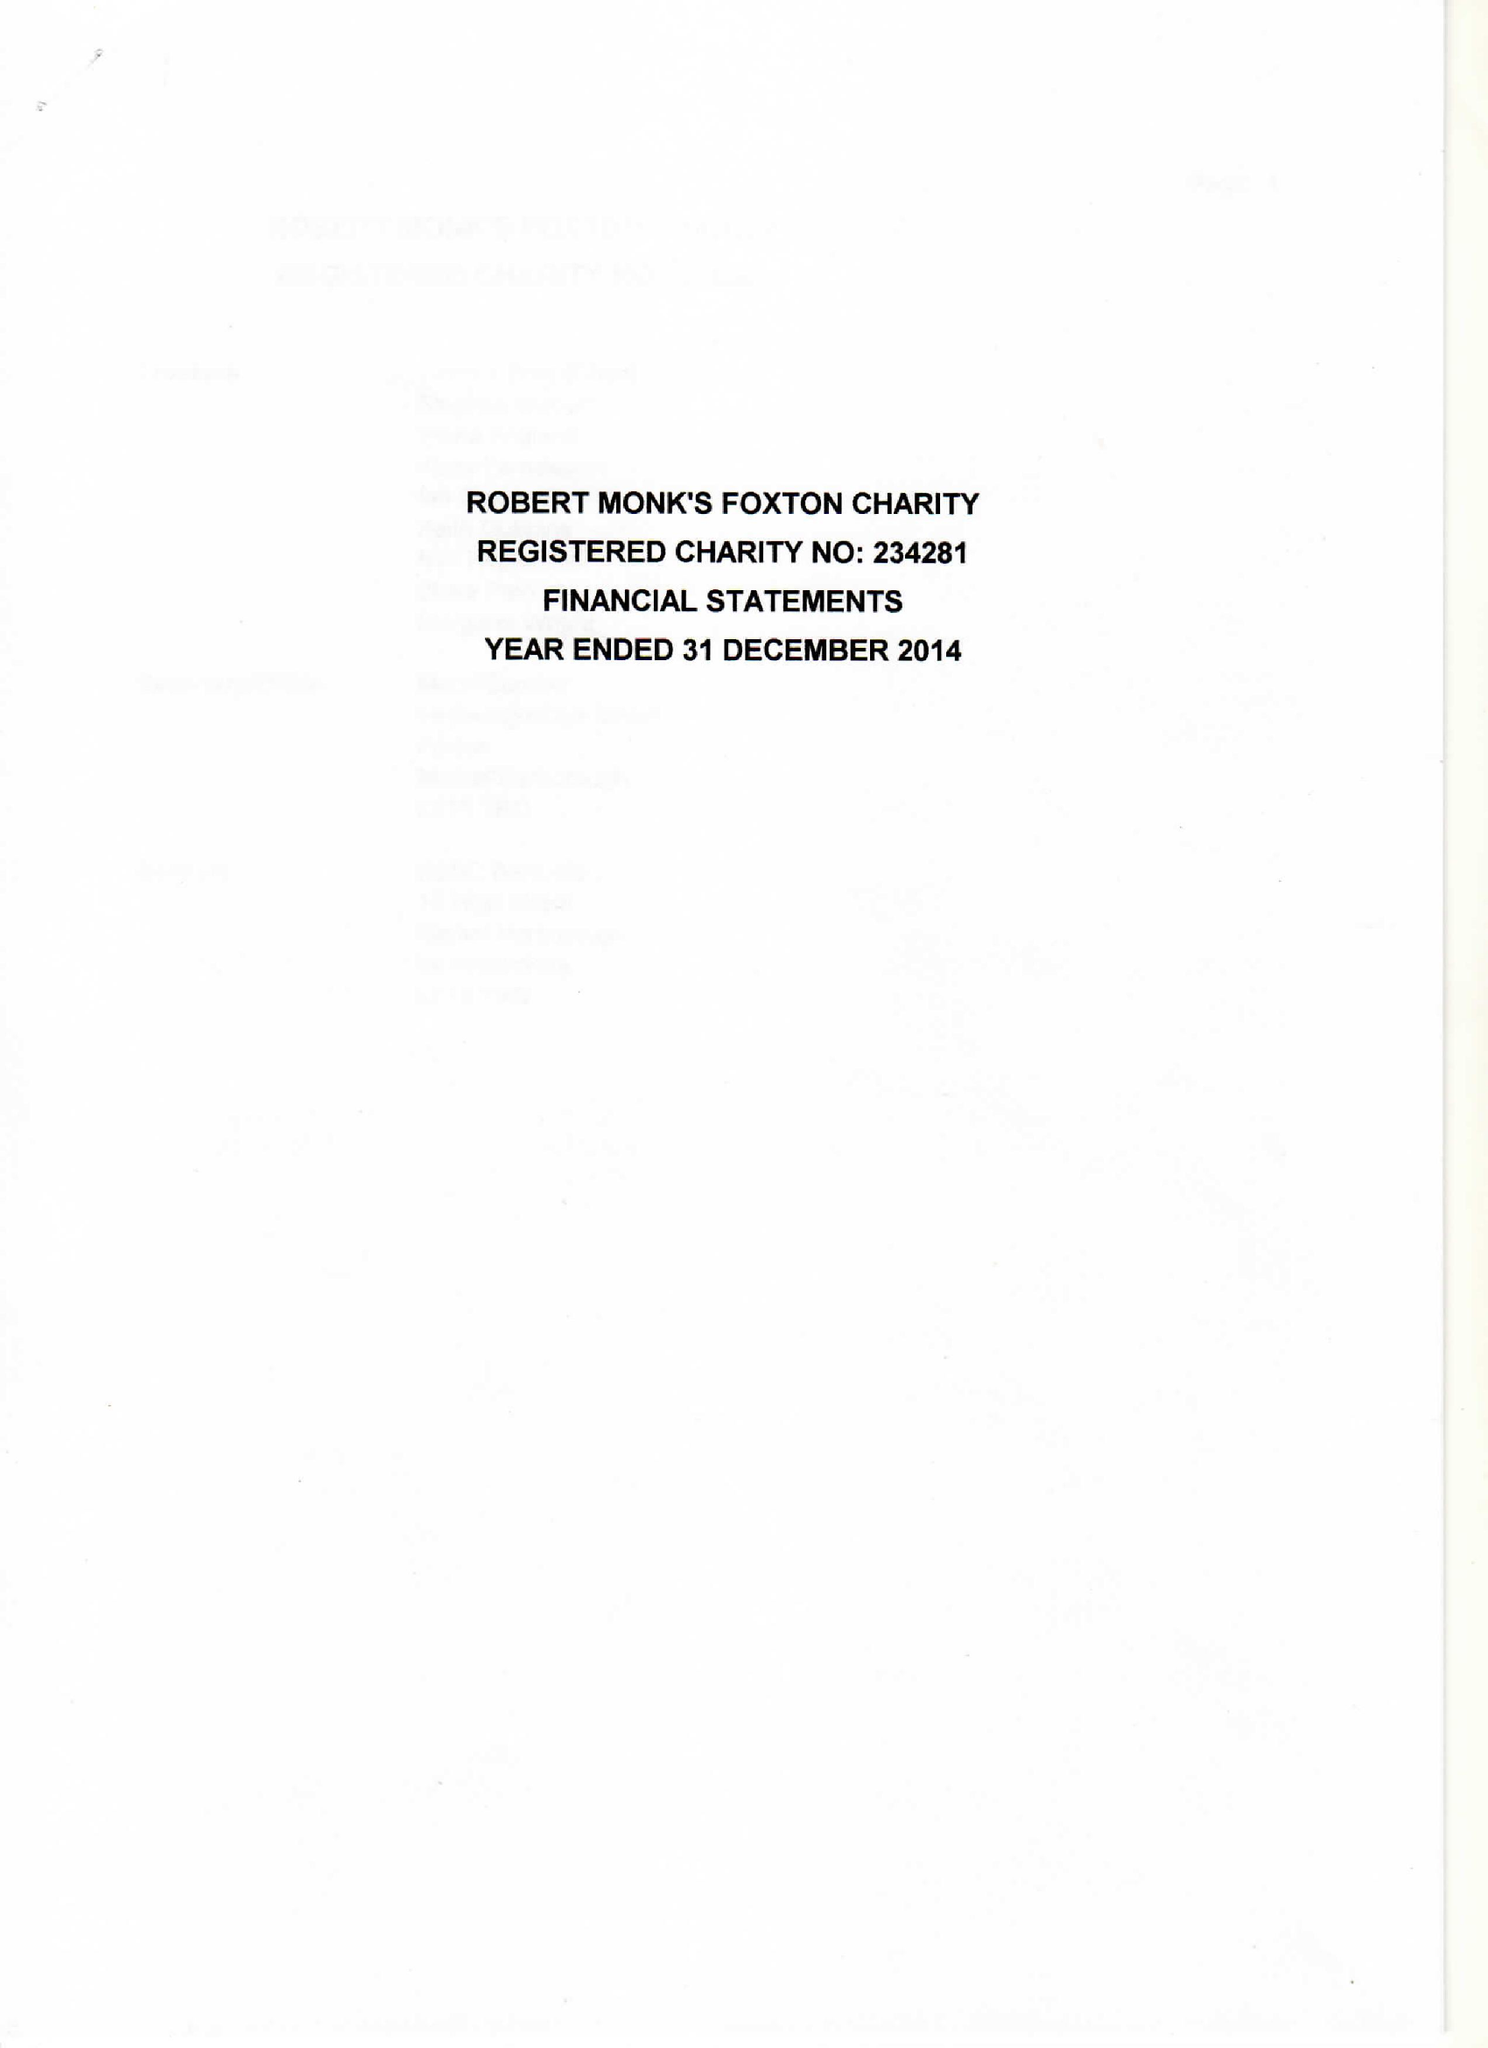What is the value for the address__post_town?
Answer the question using a single word or phrase. MARKET HARBOROUGH 